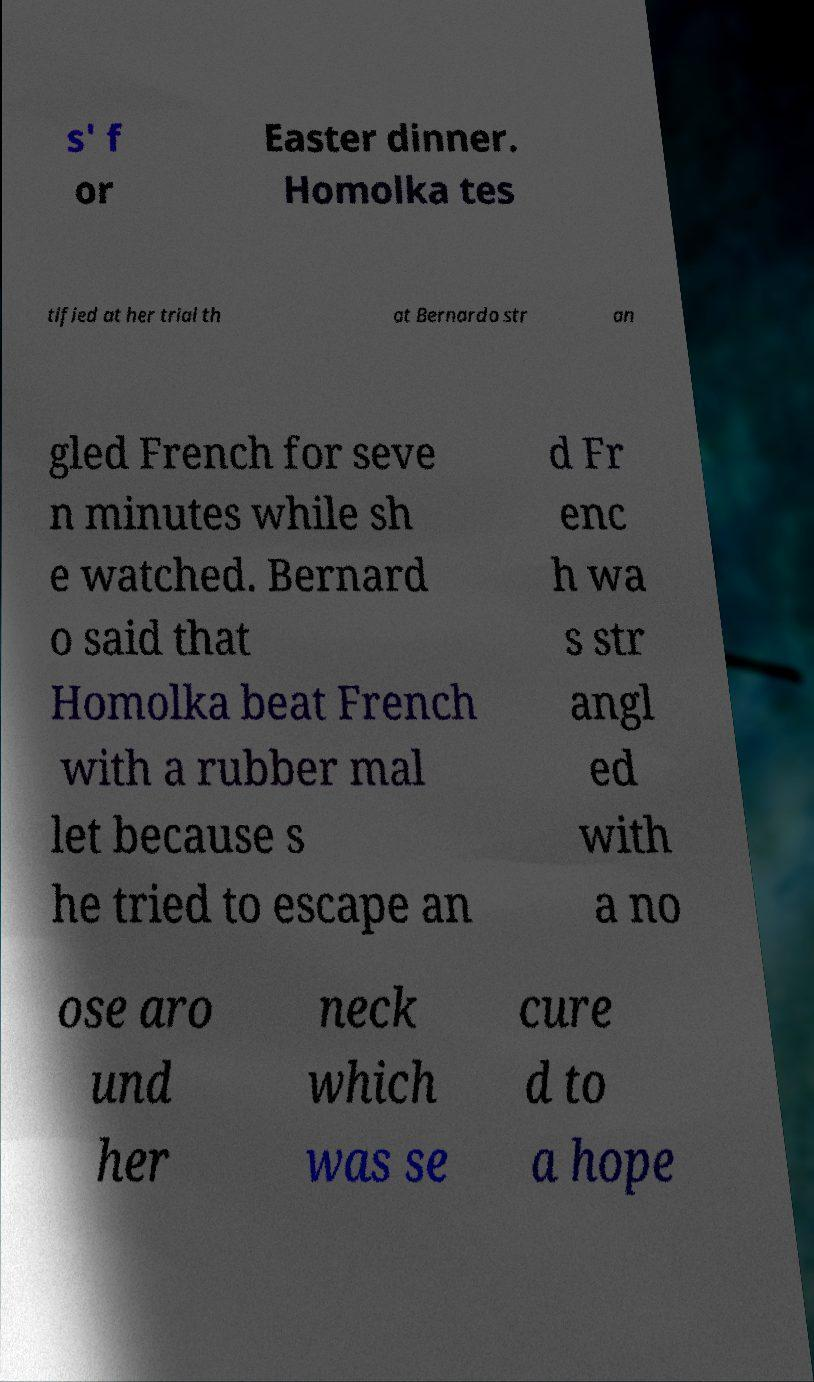For documentation purposes, I need the text within this image transcribed. Could you provide that? s' f or Easter dinner. Homolka tes tified at her trial th at Bernardo str an gled French for seve n minutes while sh e watched. Bernard o said that Homolka beat French with a rubber mal let because s he tried to escape an d Fr enc h wa s str angl ed with a no ose aro und her neck which was se cure d to a hope 